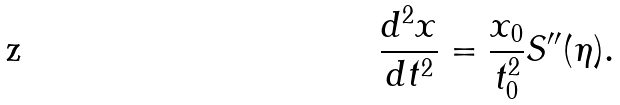Convert formula to latex. <formula><loc_0><loc_0><loc_500><loc_500>\frac { d ^ { 2 } x } { d t ^ { 2 } } = \frac { x _ { 0 } } { t _ { 0 } ^ { 2 } } S ^ { \prime \prime } ( \eta ) .</formula> 